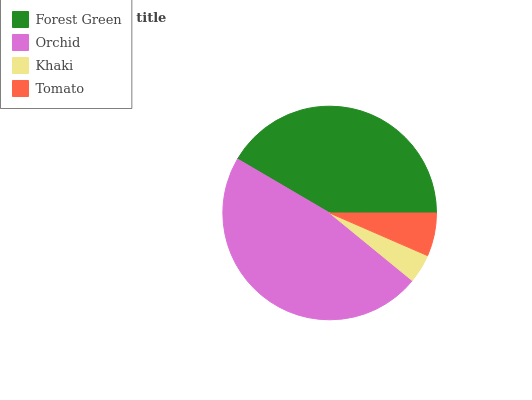Is Khaki the minimum?
Answer yes or no. Yes. Is Orchid the maximum?
Answer yes or no. Yes. Is Orchid the minimum?
Answer yes or no. No. Is Khaki the maximum?
Answer yes or no. No. Is Orchid greater than Khaki?
Answer yes or no. Yes. Is Khaki less than Orchid?
Answer yes or no. Yes. Is Khaki greater than Orchid?
Answer yes or no. No. Is Orchid less than Khaki?
Answer yes or no. No. Is Forest Green the high median?
Answer yes or no. Yes. Is Tomato the low median?
Answer yes or no. Yes. Is Tomato the high median?
Answer yes or no. No. Is Forest Green the low median?
Answer yes or no. No. 